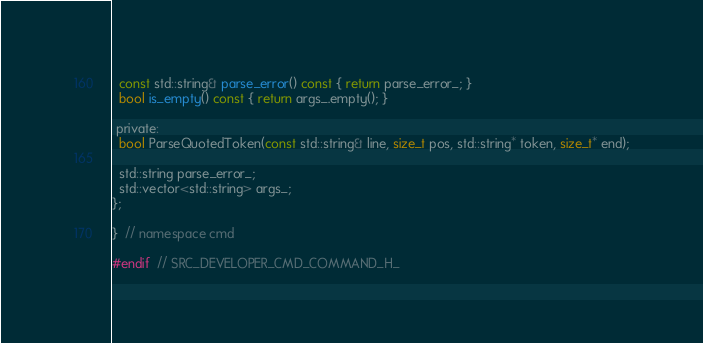<code> <loc_0><loc_0><loc_500><loc_500><_C_>
  const std::string& parse_error() const { return parse_error_; }
  bool is_empty() const { return args_.empty(); }

 private:
  bool ParseQuotedToken(const std::string& line, size_t pos, std::string* token, size_t* end);

  std::string parse_error_;
  std::vector<std::string> args_;
};

}  // namespace cmd

#endif  // SRC_DEVELOPER_CMD_COMMAND_H_
</code> 